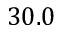Convert formula to latex. <formula><loc_0><loc_0><loc_500><loc_500>3 0 . 0</formula> 